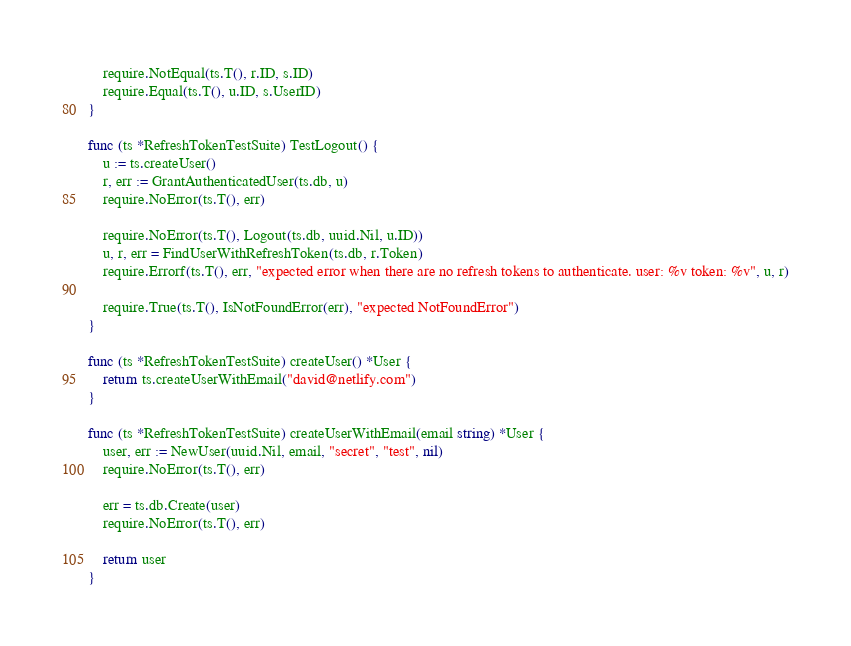<code> <loc_0><loc_0><loc_500><loc_500><_Go_>	require.NotEqual(ts.T(), r.ID, s.ID)
	require.Equal(ts.T(), u.ID, s.UserID)
}

func (ts *RefreshTokenTestSuite) TestLogout() {
	u := ts.createUser()
	r, err := GrantAuthenticatedUser(ts.db, u)
	require.NoError(ts.T(), err)

	require.NoError(ts.T(), Logout(ts.db, uuid.Nil, u.ID))
	u, r, err = FindUserWithRefreshToken(ts.db, r.Token)
	require.Errorf(ts.T(), err, "expected error when there are no refresh tokens to authenticate. user: %v token: %v", u, r)

	require.True(ts.T(), IsNotFoundError(err), "expected NotFoundError")
}

func (ts *RefreshTokenTestSuite) createUser() *User {
	return ts.createUserWithEmail("david@netlify.com")
}

func (ts *RefreshTokenTestSuite) createUserWithEmail(email string) *User {
	user, err := NewUser(uuid.Nil, email, "secret", "test", nil)
	require.NoError(ts.T(), err)

	err = ts.db.Create(user)
	require.NoError(ts.T(), err)

	return user
}
</code> 